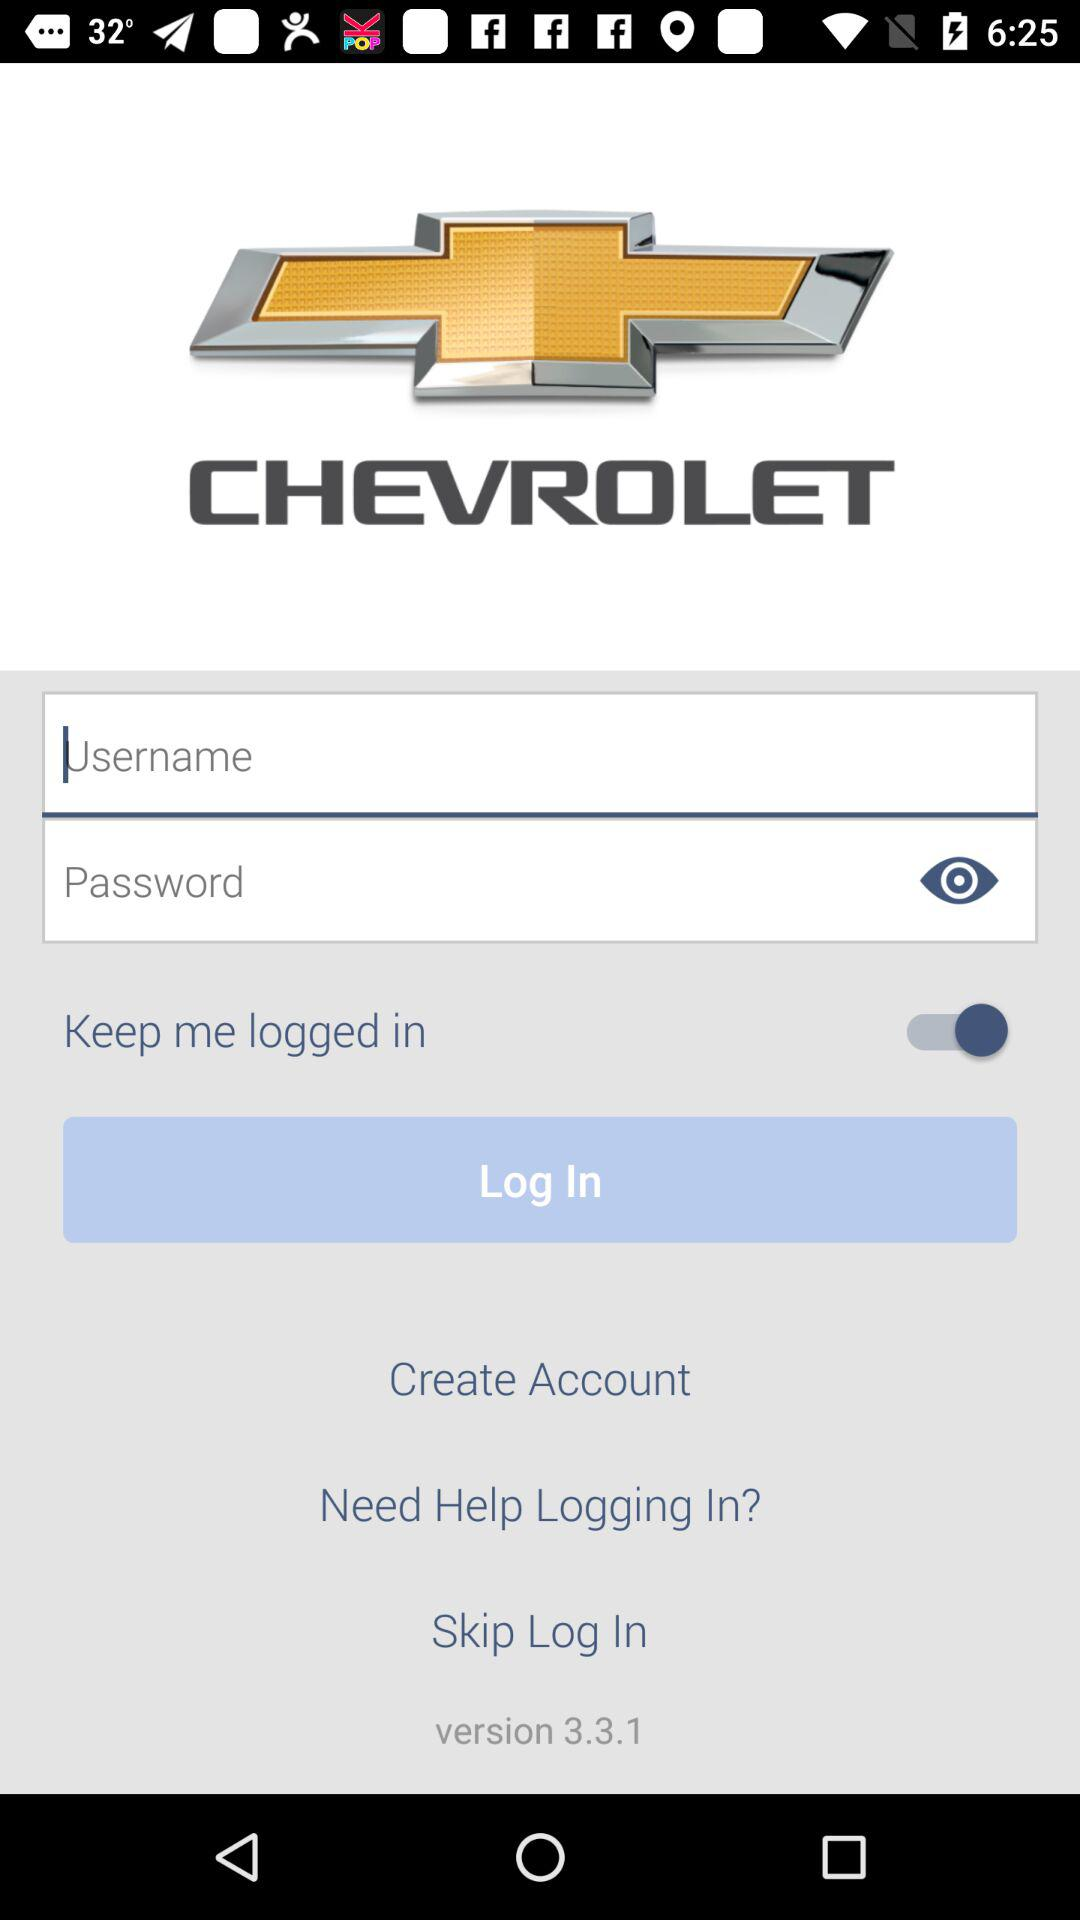What is the version of the application? The version of the application is 3.3.1. 